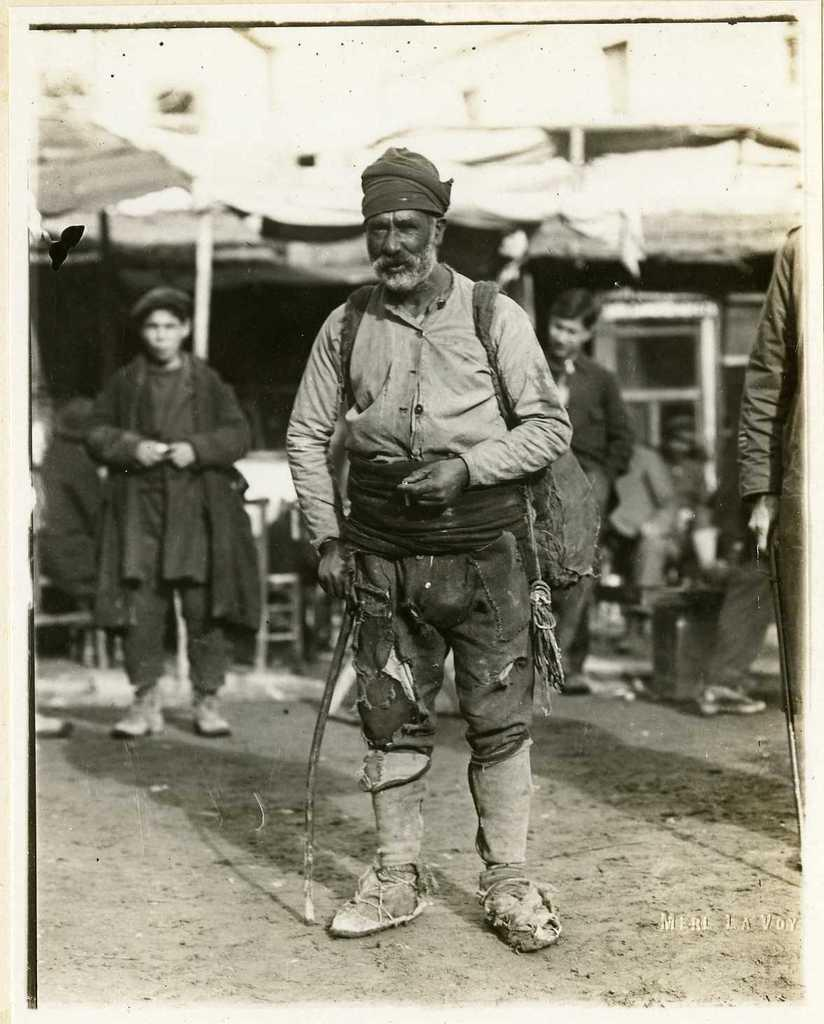What is the color scheme of the image? The image is black and white. Who or what is in the foreground of the image? There is a person standing in the foreground of the image. What is the person in the foreground wearing? The person is wearing a bag. What can be seen in the background of the image? There are people, chairs, and a house in the background of the image. What type of bun is the person holding in the image? There is no bun present in the image. Can you describe the insects flying around the person in the image? There are no insects visible in the image. 